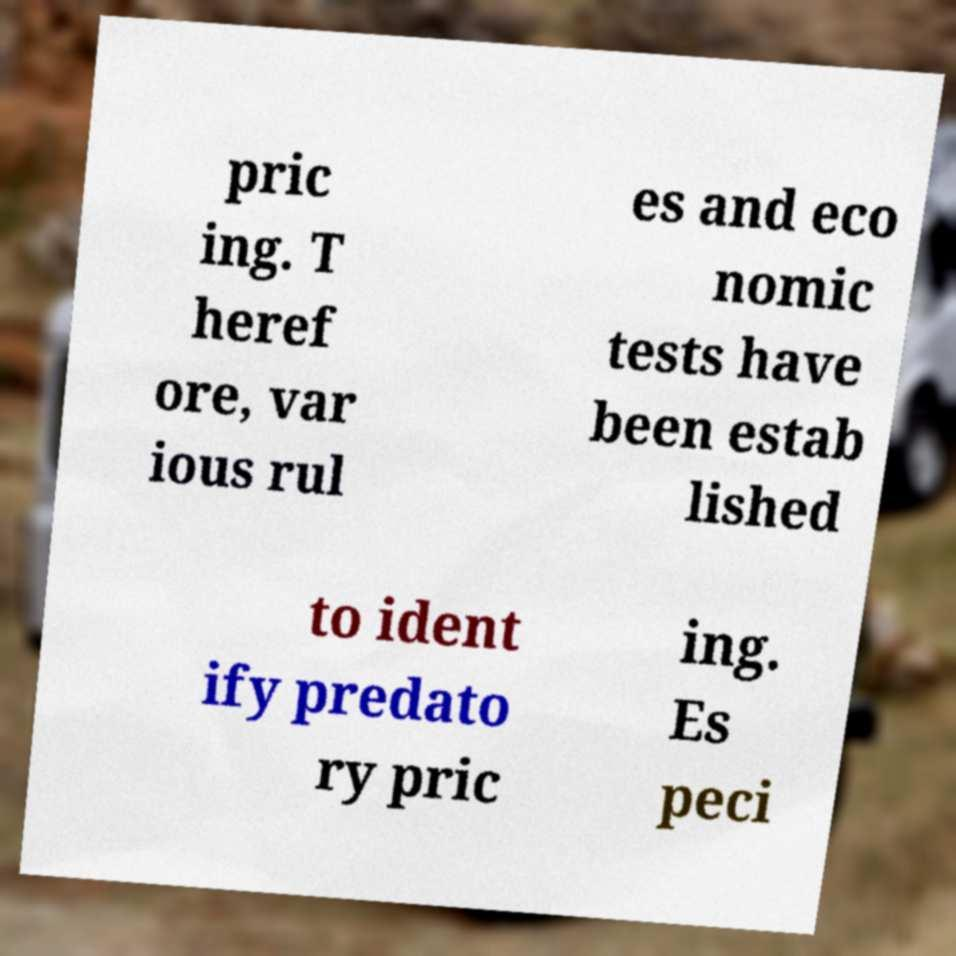Can you read and provide the text displayed in the image?This photo seems to have some interesting text. Can you extract and type it out for me? pric ing. T heref ore, var ious rul es and eco nomic tests have been estab lished to ident ify predato ry pric ing. Es peci 